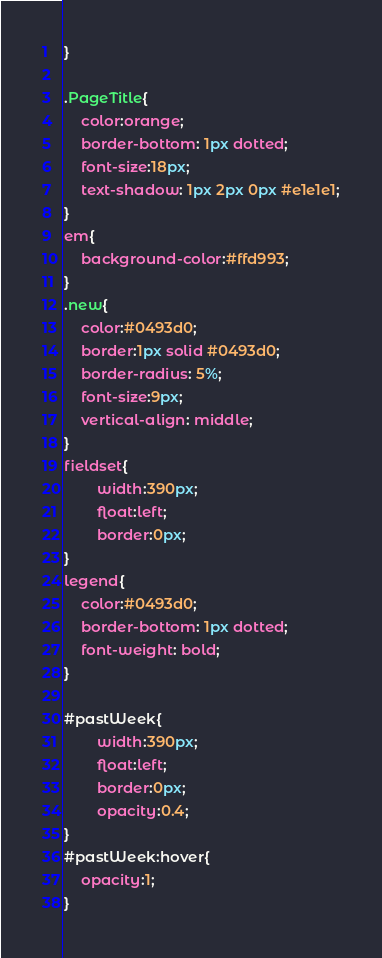<code> <loc_0><loc_0><loc_500><loc_500><_CSS_>}

.PageTitle{
	color:orange;
	border-bottom: 1px dotted;
	font-size:18px;
	text-shadow: 1px 2px 0px #e1e1e1;
}
em{
	background-color:#ffd993;
}
.new{
	color:#0493d0;
	border:1px solid #0493d0;
	border-radius: 5%;
	font-size:9px;
	vertical-align: middle;
}
fieldset{
		width:390px;
		float:left;
		border:0px;
}
legend{
	color:#0493d0;
	border-bottom: 1px dotted;
	font-weight: bold;
}

#pastWeek{
		width:390px;
		float:left;
		border:0px;
		opacity:0.4;
}
#pastWeek:hover{
	opacity:1;
}</code> 